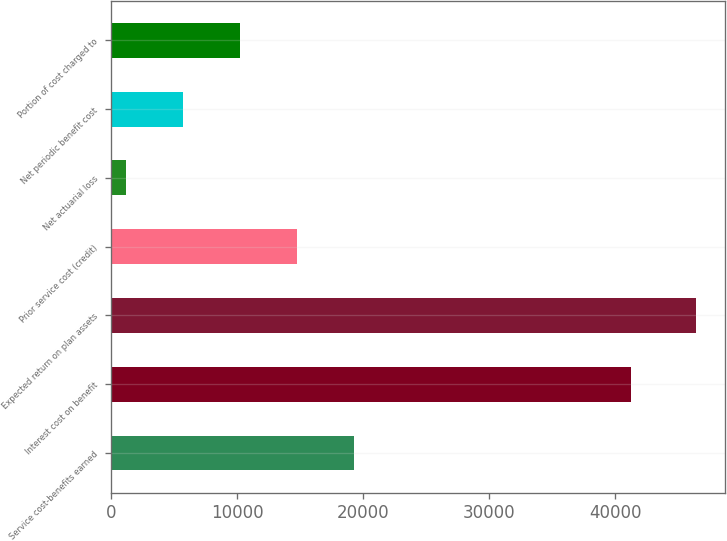Convert chart to OTSL. <chart><loc_0><loc_0><loc_500><loc_500><bar_chart><fcel>Service cost-benefits earned<fcel>Interest cost on benefit<fcel>Expected return on plan assets<fcel>Prior service cost (credit)<fcel>Net actuarial loss<fcel>Net periodic benefit cost<fcel>Portion of cost charged to<nl><fcel>19265<fcel>41243<fcel>46400<fcel>14742.5<fcel>1175<fcel>5697.5<fcel>10220<nl></chart> 